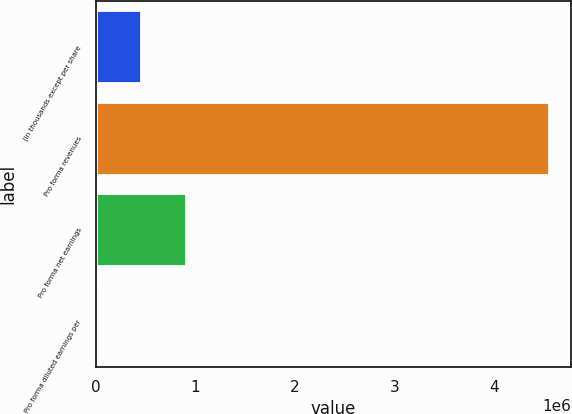Convert chart. <chart><loc_0><loc_0><loc_500><loc_500><bar_chart><fcel>(In thousands except per share<fcel>Pro forma revenues<fcel>Pro forma net earnings<fcel>Pro forma diluted earnings per<nl><fcel>454940<fcel>4.54939e+06<fcel>909878<fcel>1.32<nl></chart> 